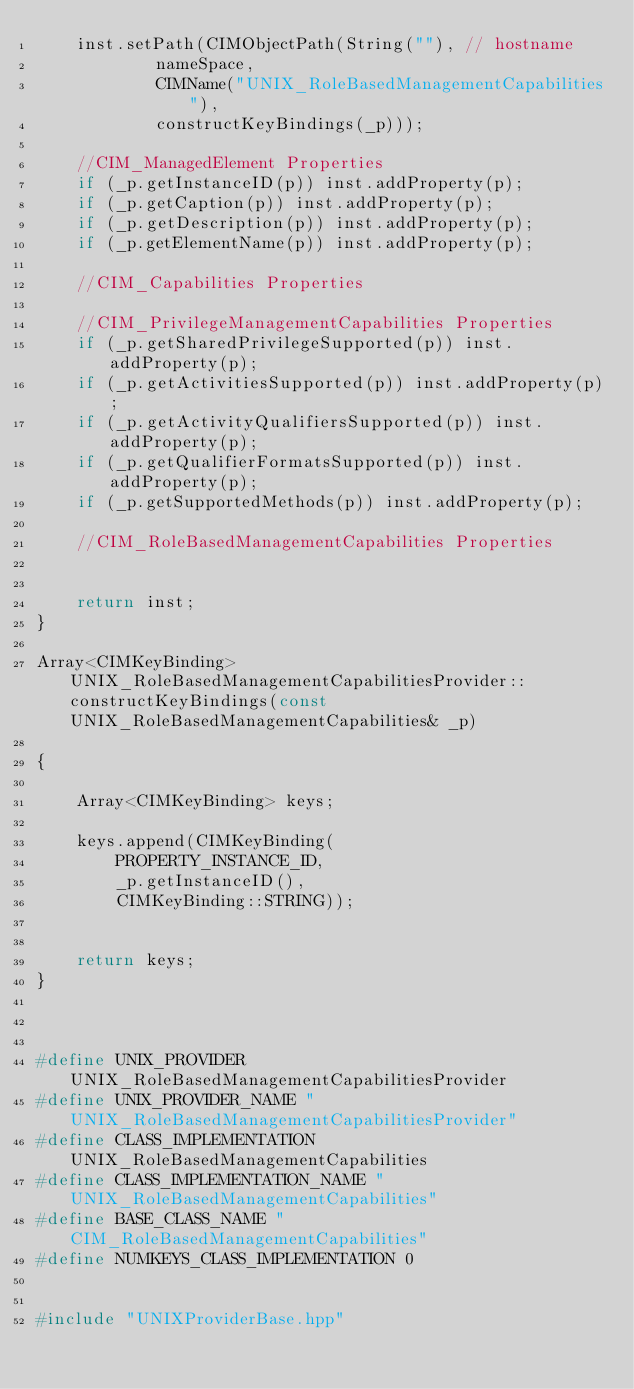Convert code to text. <code><loc_0><loc_0><loc_500><loc_500><_C++_>	inst.setPath(CIMObjectPath(String(""), // hostname
			nameSpace,
			CIMName("UNIX_RoleBasedManagementCapabilities"),
			constructKeyBindings(_p)));

	//CIM_ManagedElement Properties
	if (_p.getInstanceID(p)) inst.addProperty(p);
	if (_p.getCaption(p)) inst.addProperty(p);
	if (_p.getDescription(p)) inst.addProperty(p);
	if (_p.getElementName(p)) inst.addProperty(p);

	//CIM_Capabilities Properties

	//CIM_PrivilegeManagementCapabilities Properties
	if (_p.getSharedPrivilegeSupported(p)) inst.addProperty(p);
	if (_p.getActivitiesSupported(p)) inst.addProperty(p);
	if (_p.getActivityQualifiersSupported(p)) inst.addProperty(p);
	if (_p.getQualifierFormatsSupported(p)) inst.addProperty(p);
	if (_p.getSupportedMethods(p)) inst.addProperty(p);

	//CIM_RoleBasedManagementCapabilities Properties


	return inst;
}

Array<CIMKeyBinding> UNIX_RoleBasedManagementCapabilitiesProvider::constructKeyBindings(const UNIX_RoleBasedManagementCapabilities& _p)

{

	Array<CIMKeyBinding> keys;

	keys.append(CIMKeyBinding(
		PROPERTY_INSTANCE_ID,
		_p.getInstanceID(),
		CIMKeyBinding::STRING));


	return keys;
}



#define UNIX_PROVIDER UNIX_RoleBasedManagementCapabilitiesProvider
#define UNIX_PROVIDER_NAME "UNIX_RoleBasedManagementCapabilitiesProvider"
#define CLASS_IMPLEMENTATION UNIX_RoleBasedManagementCapabilities
#define CLASS_IMPLEMENTATION_NAME "UNIX_RoleBasedManagementCapabilities"
#define BASE_CLASS_NAME "CIM_RoleBasedManagementCapabilities"
#define NUMKEYS_CLASS_IMPLEMENTATION 0


#include "UNIXProviderBase.hpp"

</code> 